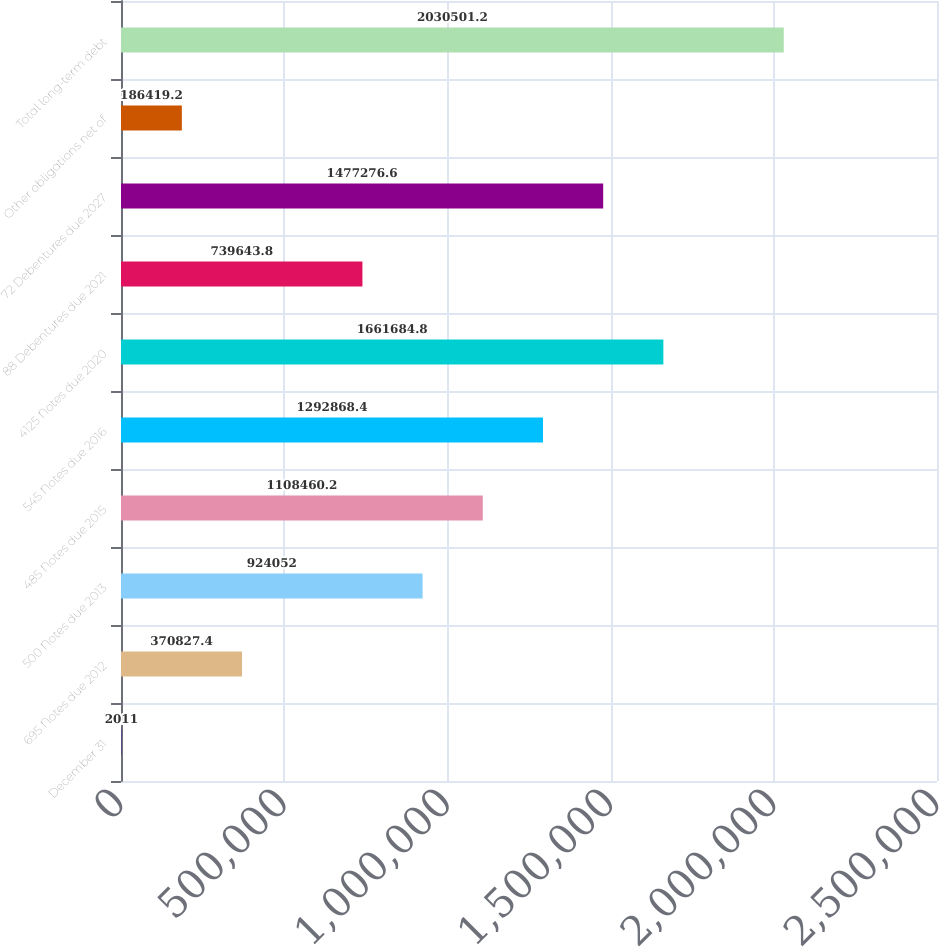<chart> <loc_0><loc_0><loc_500><loc_500><bar_chart><fcel>December 31<fcel>695 Notes due 2012<fcel>500 Notes due 2013<fcel>485 Notes due 2015<fcel>545 Notes due 2016<fcel>4125 Notes due 2020<fcel>88 Debentures due 2021<fcel>72 Debentures due 2027<fcel>Other obligations net of<fcel>Total long-term debt<nl><fcel>2011<fcel>370827<fcel>924052<fcel>1.10846e+06<fcel>1.29287e+06<fcel>1.66168e+06<fcel>739644<fcel>1.47728e+06<fcel>186419<fcel>2.0305e+06<nl></chart> 